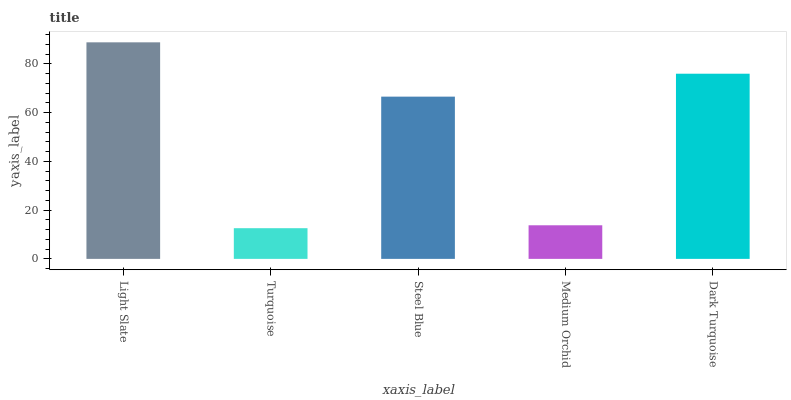Is Turquoise the minimum?
Answer yes or no. Yes. Is Light Slate the maximum?
Answer yes or no. Yes. Is Steel Blue the minimum?
Answer yes or no. No. Is Steel Blue the maximum?
Answer yes or no. No. Is Steel Blue greater than Turquoise?
Answer yes or no. Yes. Is Turquoise less than Steel Blue?
Answer yes or no. Yes. Is Turquoise greater than Steel Blue?
Answer yes or no. No. Is Steel Blue less than Turquoise?
Answer yes or no. No. Is Steel Blue the high median?
Answer yes or no. Yes. Is Steel Blue the low median?
Answer yes or no. Yes. Is Turquoise the high median?
Answer yes or no. No. Is Dark Turquoise the low median?
Answer yes or no. No. 